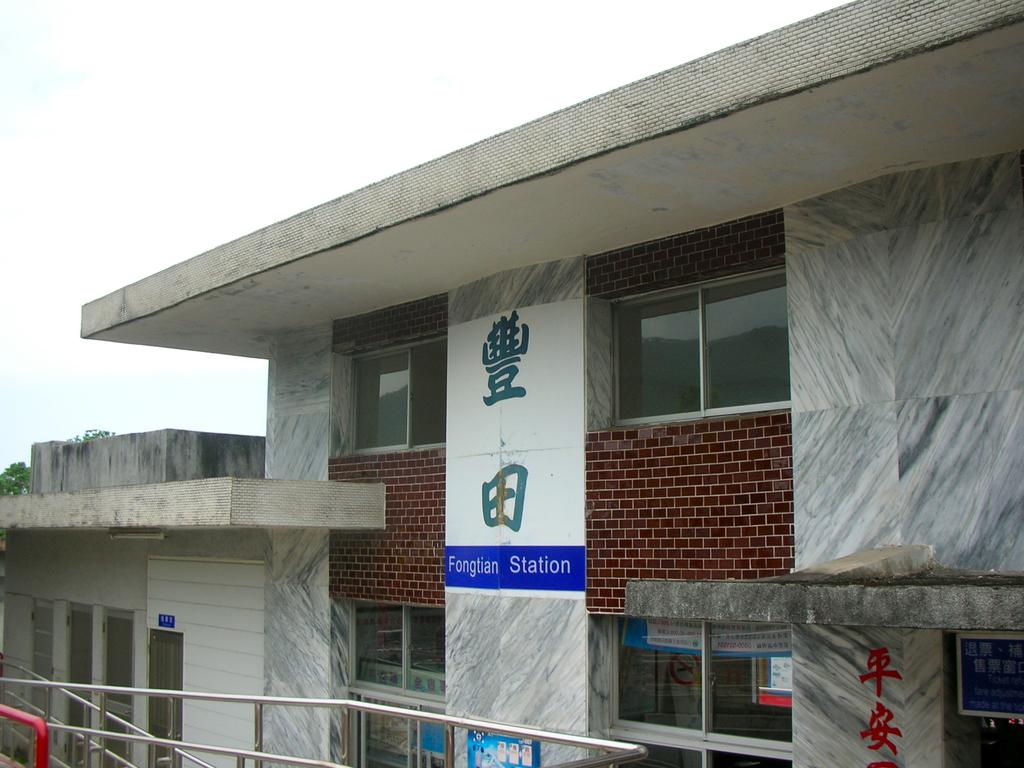What type of structure is present in the image? There is a building in the image. What can be seen on the building or nearby? There are posters in the image. What type of transportation infrastructure is visible in the image? There are roads visible in the image. What type of vegetation is present in the image? There are trees in the image. What is visible in the background of the image? The sky is visible in the background of the image. How many sticks are being used by the spy in the image? There is no spy or sticks present in the image. 